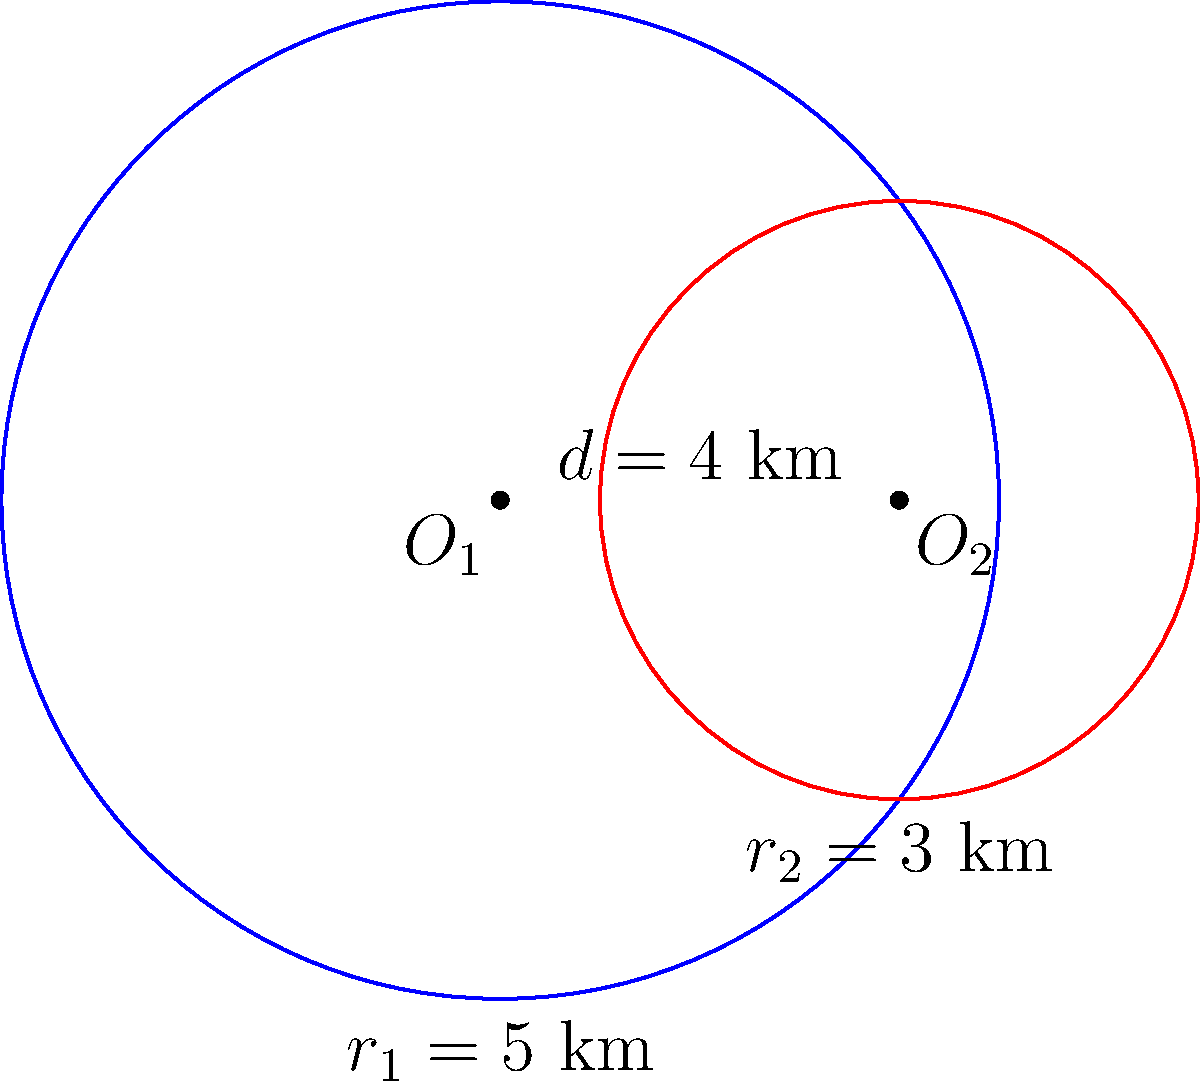In Haut-Rhin's 2nd constituency, two community centers have overlapping service areas. The centers are represented by circles with radii $r_1 = 5$ km and $r_2 = 3$ km, and their centers are 4 km apart. Calculate the area of the overlapping region to determine the number of residents who can access both centers. Use $\pi \approx 3.14$ for calculations. To find the area of overlap between two circles, we'll use the formula for the area of intersection:

1) First, calculate the distance $x$ from the center of each circle to the chord of intersection:

   For circle 1: $x_1 = \frac{r_1^2 - r_2^2 + d^2}{2d} = \frac{5^2 - 3^2 + 4^2}{2(4)} = 3.5$ km
   For circle 2: $x_2 = d - x_1 = 4 - 3.5 = 0.5$ km

2) Calculate the central angle $\theta$ for each circle:

   $\theta_1 = 2 \arccos(\frac{x_1}{r_1}) = 2 \arccos(\frac{3.5}{5}) \approx 1.855$ radians
   $\theta_2 = 2 \arccos(\frac{x_2}{r_2}) = 2 \arccos(\frac{0.5}{3}) \approx 2.820$ radians

3) Calculate the area of each sector:

   $A_{sector1} = \frac{1}{2} r_1^2 \theta_1 = \frac{1}{2} (5^2) (1.855) \approx 23.188$ km²
   $A_{sector2} = \frac{1}{2} r_2^2 \theta_2 = \frac{1}{2} (3^2) (2.820) \approx 12.690$ km²

4) Calculate the area of each triangle:

   $A_{triangle1} = \frac{1}{2} r_1^2 \sin(\theta_1) = \frac{1}{2} (5^2) \sin(1.855) \approx 11.559$ km²
   $A_{triangle2} = \frac{1}{2} r_2^2 \sin(\theta_2) = \frac{1}{2} (3^2) \sin(2.820) \approx 4.303$ km²

5) The area of overlap is the sum of the sectors minus the sum of the triangles:

   $A_{overlap} = (A_{sector1} + A_{sector2}) - (A_{triangle1} + A_{triangle2})$
   $A_{overlap} = (23.188 + 12.690) - (11.559 + 4.303) \approx 20.016$ km²

Therefore, the area of overlap is approximately 20.016 km².
Answer: 20.016 km² 